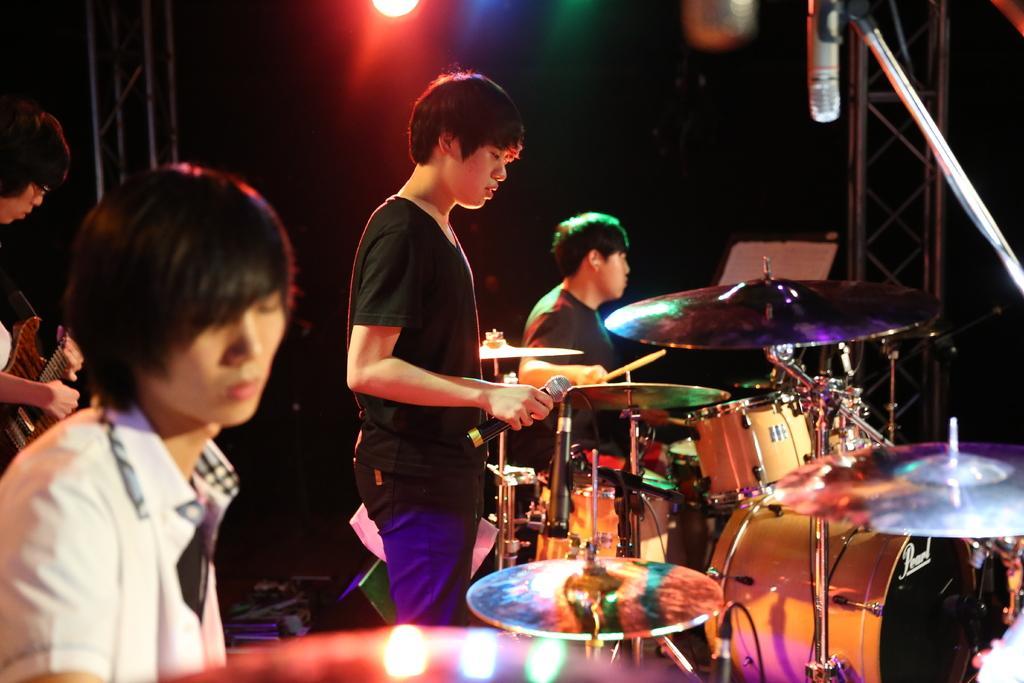Can you describe this image briefly? In the foreground I can see four persons are playing musical instruments on the stage. In the background I can see metal rods, focus lights and dark color. This image is taken during night on the stage. 